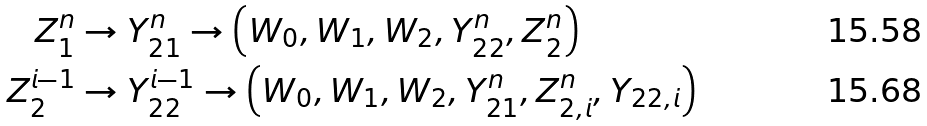Convert formula to latex. <formula><loc_0><loc_0><loc_500><loc_500>Z _ { 1 } ^ { n } & \rightarrow Y _ { 2 1 } ^ { n } \rightarrow \left ( W _ { 0 } , W _ { 1 } , W _ { 2 } , Y _ { 2 2 } ^ { n } , Z _ { 2 } ^ { n } \right ) \\ Z _ { 2 } ^ { i - 1 } & \rightarrow Y _ { 2 2 } ^ { i - 1 } \rightarrow \left ( W _ { 0 } , W _ { 1 } , W _ { 2 } , Y _ { 2 1 } ^ { n } , Z _ { 2 , i } ^ { n } , Y _ { 2 2 , i } \right )</formula> 